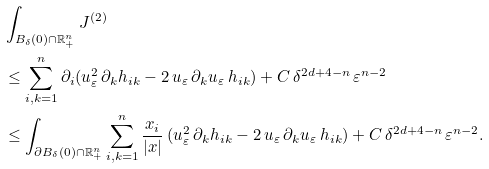<formula> <loc_0><loc_0><loc_500><loc_500>& \int _ { B _ { \delta } ( 0 ) \cap \mathbb { R } _ { + } ^ { n } } J ^ { ( 2 ) } \\ & \leq \sum _ { i , k = 1 } ^ { n } \partial _ { i } ( u _ { \varepsilon } ^ { 2 } \, \partial _ { k } h _ { i k } - 2 \, u _ { \varepsilon } \, \partial _ { k } u _ { \varepsilon } \, h _ { i k } ) + C \, \delta ^ { 2 d + 4 - n } \, \varepsilon ^ { n - 2 } \\ & \leq \int _ { \partial B _ { \delta } ( 0 ) \cap \mathbb { R } _ { + } ^ { n } } \sum _ { i , k = 1 } ^ { n } \frac { x _ { i } } { | x | } \, ( u _ { \varepsilon } ^ { 2 } \, \partial _ { k } h _ { i k } - 2 \, u _ { \varepsilon } \, \partial _ { k } u _ { \varepsilon } \, h _ { i k } ) + C \, \delta ^ { 2 d + 4 - n } \, \varepsilon ^ { n - 2 } .</formula> 